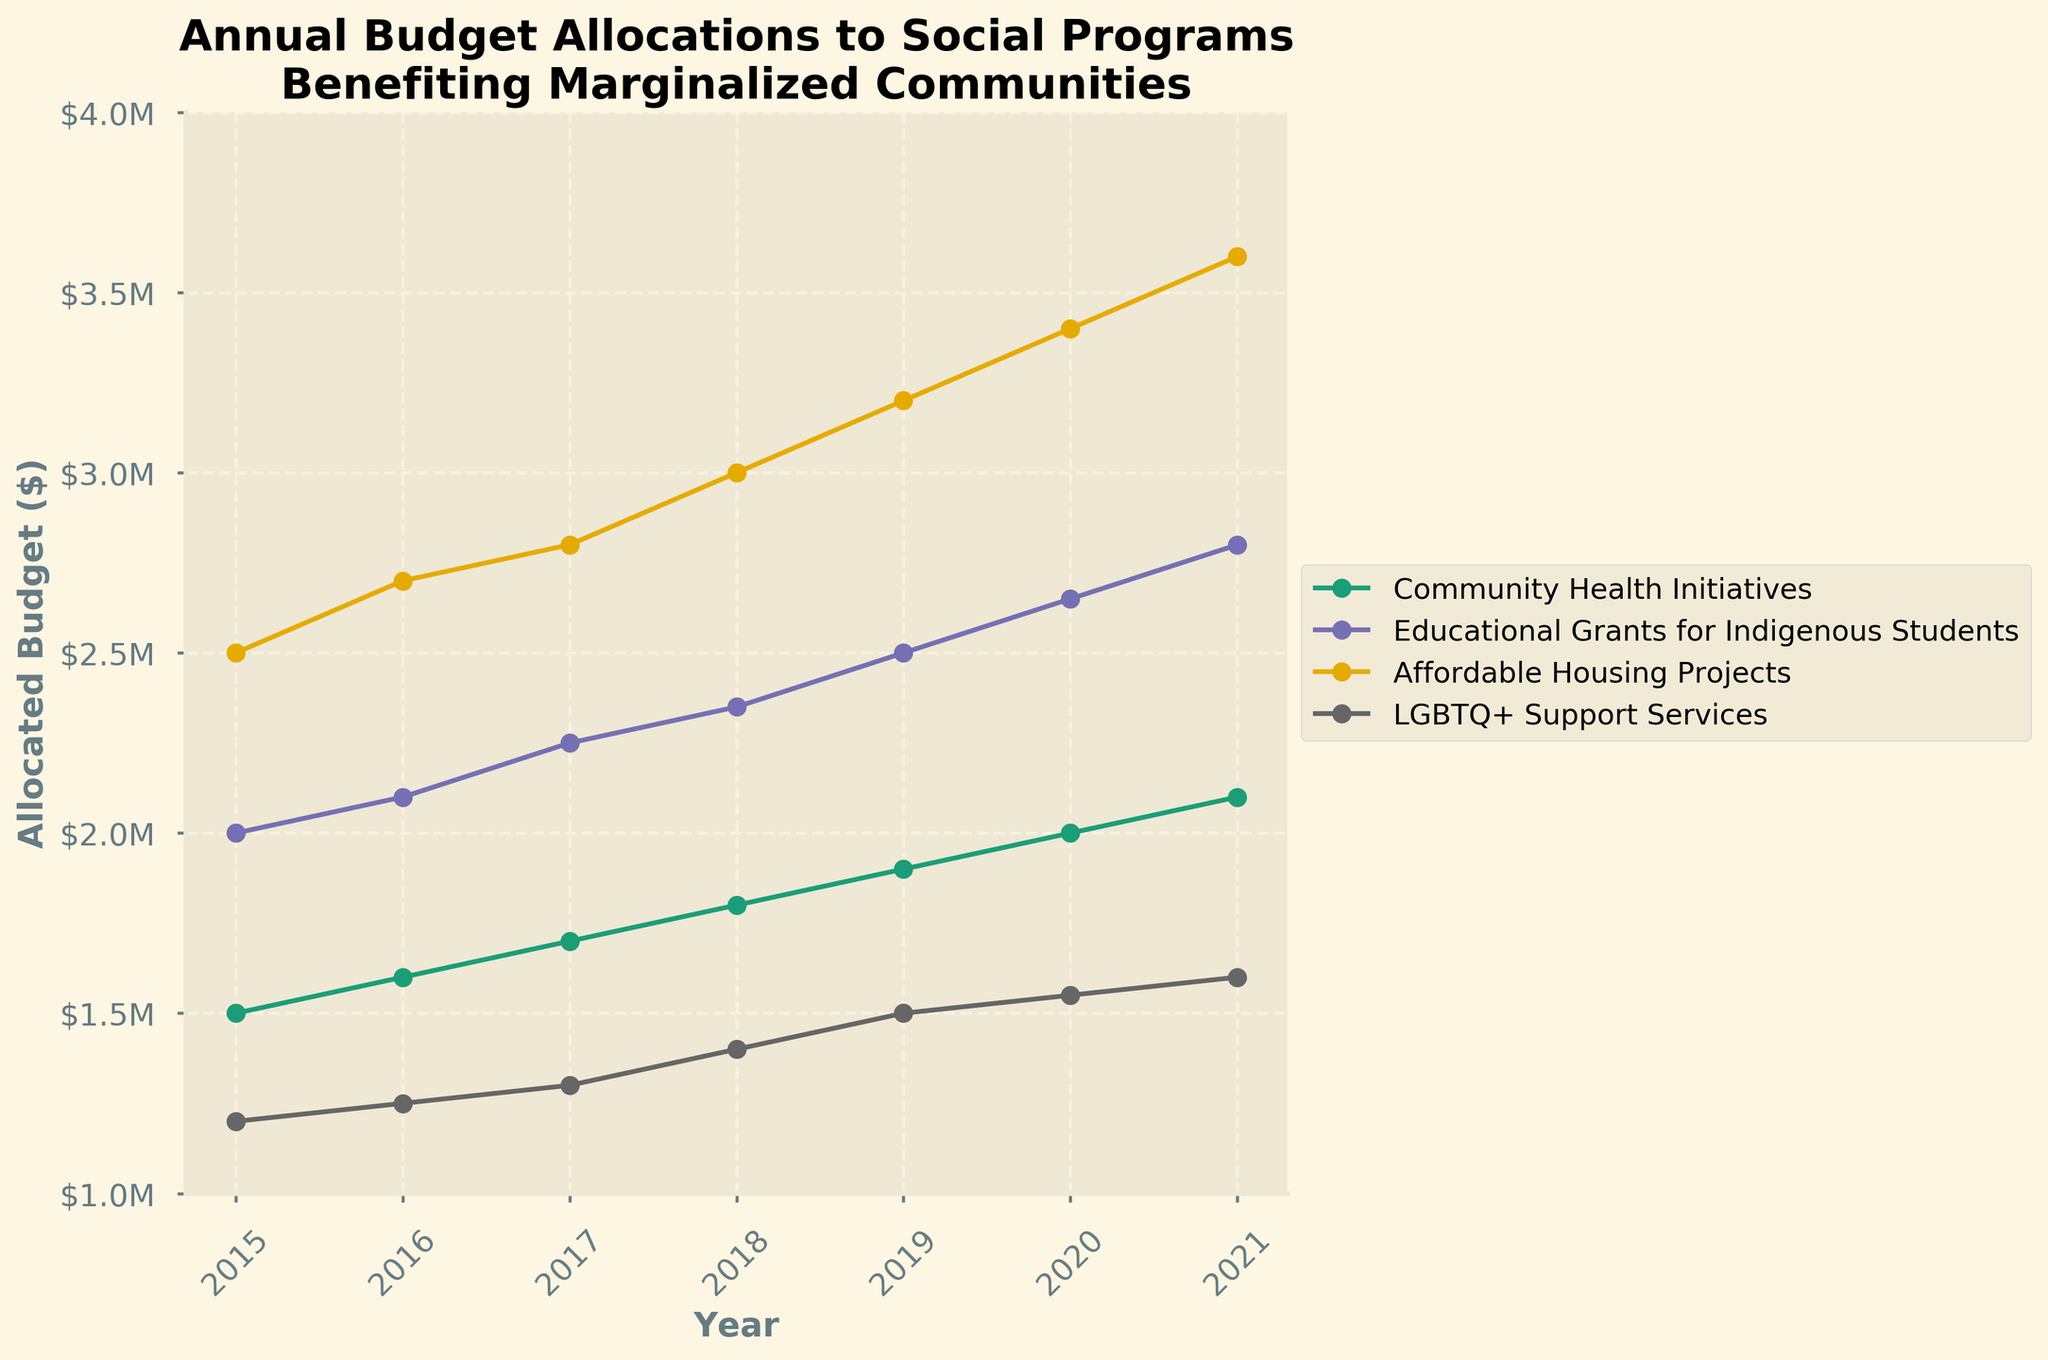What's the title of the plot? The title is prominently displayed at the top of the plot, providing an overview of the content. It reads "Annual Budget Allocations to Social Programs\nBenefiting Marginalized Communities".
Answer: Annual Budget Allocations to Social Programs Benefiting Marginalized Communities Which program had the highest budget allocation in 2020? The plot shows lines representing each program's budget over the years. For 2020, the line for "Affordable Housing Projects" reaches the highest point.
Answer: Affordable Housing Projects What is the total budget allocated to Community Health Initiatives from 2015 to 2021? Sum the budget amounts for Community Health Initiatives from each year shown: 1500000 + 1600000 + 1700000 + 1800000 + 1900000 + 2000000 + 2100000 = 1,260,000.
Answer: $1.26M How has the budget for LGBTQ+ Support Services changed from 2015 to 2021? Find the allocated budgets for the years 2015 and 2021 from the plot and calculate the difference: 1,600,000 - 1,200,000 = 400,000. The budget increased by 400,000.
Answer: Increased by $400,000 Which year shows the largest increase in budget allocation for Affordable Housing Projects compared to the previous year? Check the differences year over year: 
2016 vs. 2015: 2700000 - 2500000 = 200000,
2017 vs. 2016: 2800000 - 2700000 = 100000,
2018 vs. 2017: 3000000 - 2800000 = 200000,
2019 vs. 2018: 3200000 - 3000000 = 200000,
2020 vs. 2019: 3400000 - 3200000 = 200000,
2021 vs. 2020: 3600000 - 3400000 = 200000. 
This increase is consistent each year after initially.
Answer: 2019 and 2021 What is the average budget for Educational Grants for Indigenous Students between 2015 and 2021? Calculate the average by summing the budget allocations and dividing by the number of years: (2000000 + 2100000 + 2250000 + 2350000 + 2500000 + 2650000 + 2800000) / 7 = 2,380,00.
Answer: $2.38M In which year did all programs experience a budget increase compared to the previous year? By checking each plot's line trend, we observe that every program's budget allocation increases each year.
Answer: Every year Which program had the smallest budget in 2015, and what was the amount? In 2015, the program with the lowest line on the plot is "LGBTQ+ Support Services" with an allocation of $1,200,000.
Answer: LGBTQ+ Support Services, $1.2M Compare the budget allocation trends for Community Health Initiatives and Educational Grants for Indigenous Students from 2015 to 2021. Which program had higher growth? For Community Health Initiatives: 
growth = 2015: 1,500,000 to 2021: 2,100,000; difference = 600,000.
For Educational Grants for Indigenous Students: 
2015: 2,000,000 to 2021: 2,800,000; difference = 800,000.
Educational Grants for Indigenous Students had higher growth.
Answer: Educational Grants for Indigenous Students What is the percentage change in the budget allocation for LGBTQ+ Support Services from 2015 to 2021? Calculate the percentage change using the formula: 
((2021 amount - 2015 amount) / 2015 amount) * 100
((1600000 - 1200000) / 1200000) * 100 = 33.33%. 
The budget increased by 33.33%.
Answer: 33.33% 